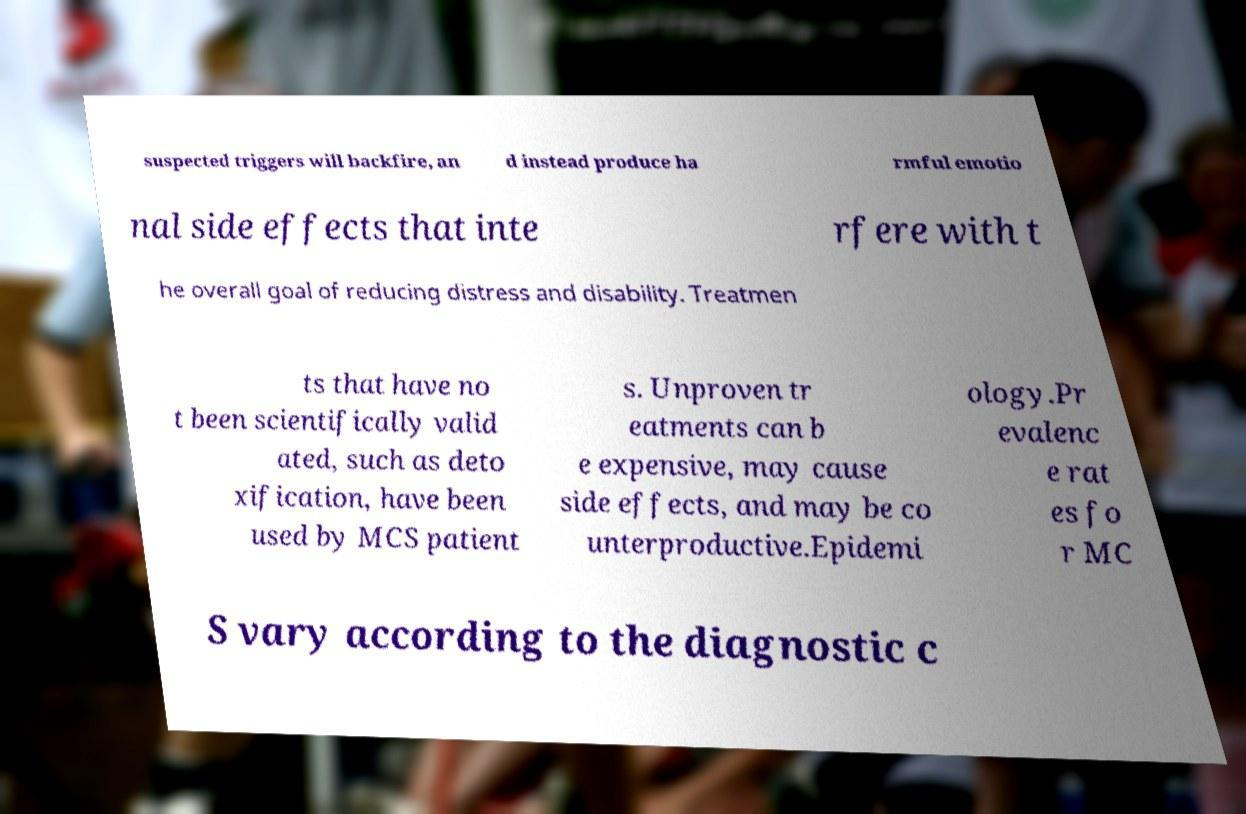For documentation purposes, I need the text within this image transcribed. Could you provide that? suspected triggers will backfire, an d instead produce ha rmful emotio nal side effects that inte rfere with t he overall goal of reducing distress and disability. Treatmen ts that have no t been scientifically valid ated, such as deto xification, have been used by MCS patient s. Unproven tr eatments can b e expensive, may cause side effects, and may be co unterproductive.Epidemi ology.Pr evalenc e rat es fo r MC S vary according to the diagnostic c 